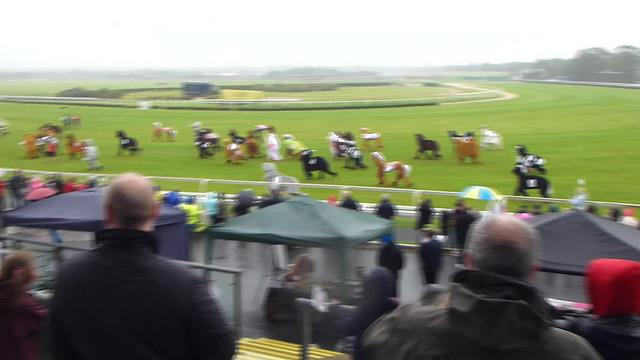How many awnings are there? three 